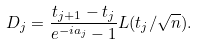Convert formula to latex. <formula><loc_0><loc_0><loc_500><loc_500>D _ { j } = \frac { t _ { j + 1 } - t _ { j } } { e ^ { - i a _ { j } } - 1 } L ( t _ { j } / \sqrt { n } ) .</formula> 